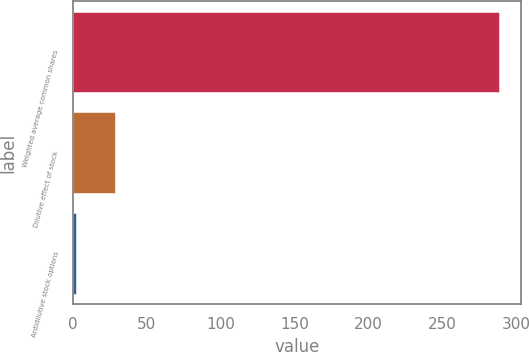Convert chart to OTSL. <chart><loc_0><loc_0><loc_500><loc_500><bar_chart><fcel>Weighted average common shares<fcel>Dilutive effect of stock<fcel>Antidilutive stock options<nl><fcel>288.7<fcel>28.7<fcel>2.2<nl></chart> 